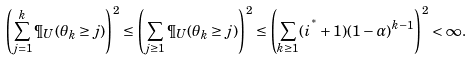Convert formula to latex. <formula><loc_0><loc_0><loc_500><loc_500>\left ( \sum _ { j = 1 } ^ { k } \P _ { U } ( { \theta _ { k } } \geq j ) \right ) ^ { 2 } \leq \left ( \sum _ { j \geq 1 } \P _ { U } ( { \theta _ { k } } \geq j ) \right ) ^ { 2 } \leq \left ( \sum _ { k \geq 1 } ( i ^ { ^ { * } } + 1 ) ( 1 - \alpha ) ^ { k - 1 } \right ) ^ { 2 } < \infty .</formula> 